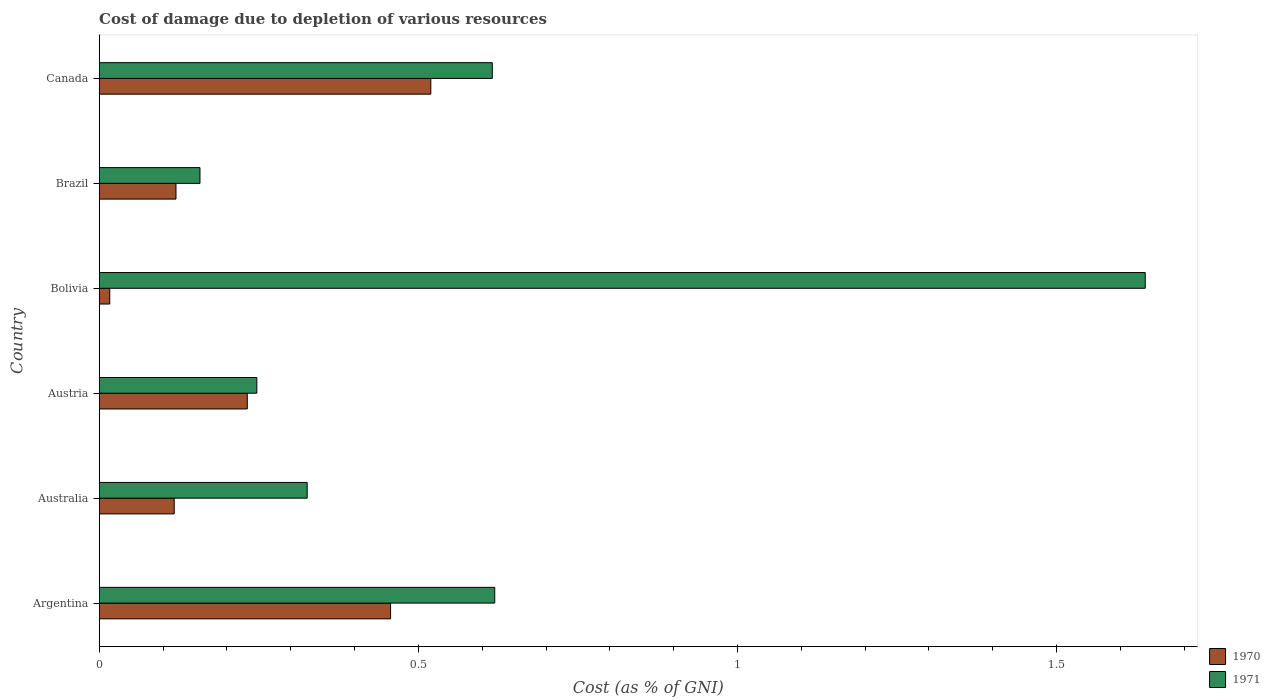How many different coloured bars are there?
Your response must be concise. 2. How many groups of bars are there?
Offer a very short reply. 6. Are the number of bars on each tick of the Y-axis equal?
Offer a terse response. Yes. How many bars are there on the 4th tick from the bottom?
Keep it short and to the point. 2. What is the label of the 6th group of bars from the top?
Offer a terse response. Argentina. In how many cases, is the number of bars for a given country not equal to the number of legend labels?
Offer a very short reply. 0. What is the cost of damage caused due to the depletion of various resources in 1971 in Brazil?
Offer a very short reply. 0.16. Across all countries, what is the maximum cost of damage caused due to the depletion of various resources in 1970?
Provide a short and direct response. 0.52. Across all countries, what is the minimum cost of damage caused due to the depletion of various resources in 1971?
Give a very brief answer. 0.16. In which country was the cost of damage caused due to the depletion of various resources in 1970 maximum?
Offer a very short reply. Canada. What is the total cost of damage caused due to the depletion of various resources in 1970 in the graph?
Keep it short and to the point. 1.46. What is the difference between the cost of damage caused due to the depletion of various resources in 1970 in Australia and that in Brazil?
Make the answer very short. -0. What is the difference between the cost of damage caused due to the depletion of various resources in 1970 in Argentina and the cost of damage caused due to the depletion of various resources in 1971 in Australia?
Your answer should be compact. 0.13. What is the average cost of damage caused due to the depletion of various resources in 1970 per country?
Ensure brevity in your answer.  0.24. What is the difference between the cost of damage caused due to the depletion of various resources in 1970 and cost of damage caused due to the depletion of various resources in 1971 in Australia?
Your response must be concise. -0.21. In how many countries, is the cost of damage caused due to the depletion of various resources in 1970 greater than 0.4 %?
Offer a very short reply. 2. What is the ratio of the cost of damage caused due to the depletion of various resources in 1970 in Australia to that in Bolivia?
Give a very brief answer. 7.12. Is the difference between the cost of damage caused due to the depletion of various resources in 1970 in Australia and Canada greater than the difference between the cost of damage caused due to the depletion of various resources in 1971 in Australia and Canada?
Offer a terse response. No. What is the difference between the highest and the second highest cost of damage caused due to the depletion of various resources in 1971?
Ensure brevity in your answer.  1.02. What is the difference between the highest and the lowest cost of damage caused due to the depletion of various resources in 1971?
Your response must be concise. 1.48. What does the 1st bar from the top in Brazil represents?
Provide a short and direct response. 1971. Are all the bars in the graph horizontal?
Offer a very short reply. Yes. How many countries are there in the graph?
Provide a succinct answer. 6. Are the values on the major ticks of X-axis written in scientific E-notation?
Provide a short and direct response. No. Does the graph contain any zero values?
Your response must be concise. No. Does the graph contain grids?
Offer a terse response. No. Where does the legend appear in the graph?
Keep it short and to the point. Bottom right. How are the legend labels stacked?
Provide a succinct answer. Vertical. What is the title of the graph?
Your answer should be compact. Cost of damage due to depletion of various resources. Does "1966" appear as one of the legend labels in the graph?
Make the answer very short. No. What is the label or title of the X-axis?
Provide a short and direct response. Cost (as % of GNI). What is the label or title of the Y-axis?
Your answer should be compact. Country. What is the Cost (as % of GNI) in 1970 in Argentina?
Your answer should be very brief. 0.46. What is the Cost (as % of GNI) of 1971 in Argentina?
Your answer should be very brief. 0.62. What is the Cost (as % of GNI) of 1970 in Australia?
Offer a terse response. 0.12. What is the Cost (as % of GNI) of 1971 in Australia?
Ensure brevity in your answer.  0.33. What is the Cost (as % of GNI) in 1970 in Austria?
Provide a succinct answer. 0.23. What is the Cost (as % of GNI) in 1971 in Austria?
Make the answer very short. 0.25. What is the Cost (as % of GNI) of 1970 in Bolivia?
Ensure brevity in your answer.  0.02. What is the Cost (as % of GNI) in 1971 in Bolivia?
Ensure brevity in your answer.  1.64. What is the Cost (as % of GNI) of 1970 in Brazil?
Offer a very short reply. 0.12. What is the Cost (as % of GNI) in 1971 in Brazil?
Ensure brevity in your answer.  0.16. What is the Cost (as % of GNI) of 1970 in Canada?
Offer a terse response. 0.52. What is the Cost (as % of GNI) in 1971 in Canada?
Your response must be concise. 0.62. Across all countries, what is the maximum Cost (as % of GNI) in 1970?
Provide a succinct answer. 0.52. Across all countries, what is the maximum Cost (as % of GNI) in 1971?
Offer a very short reply. 1.64. Across all countries, what is the minimum Cost (as % of GNI) of 1970?
Make the answer very short. 0.02. Across all countries, what is the minimum Cost (as % of GNI) in 1971?
Your answer should be very brief. 0.16. What is the total Cost (as % of GNI) in 1970 in the graph?
Your response must be concise. 1.46. What is the total Cost (as % of GNI) of 1971 in the graph?
Ensure brevity in your answer.  3.6. What is the difference between the Cost (as % of GNI) of 1970 in Argentina and that in Australia?
Ensure brevity in your answer.  0.34. What is the difference between the Cost (as % of GNI) of 1971 in Argentina and that in Australia?
Offer a very short reply. 0.29. What is the difference between the Cost (as % of GNI) of 1970 in Argentina and that in Austria?
Ensure brevity in your answer.  0.22. What is the difference between the Cost (as % of GNI) in 1971 in Argentina and that in Austria?
Give a very brief answer. 0.37. What is the difference between the Cost (as % of GNI) of 1970 in Argentina and that in Bolivia?
Your response must be concise. 0.44. What is the difference between the Cost (as % of GNI) in 1971 in Argentina and that in Bolivia?
Provide a short and direct response. -1.02. What is the difference between the Cost (as % of GNI) in 1970 in Argentina and that in Brazil?
Your answer should be compact. 0.34. What is the difference between the Cost (as % of GNI) of 1971 in Argentina and that in Brazil?
Your answer should be very brief. 0.46. What is the difference between the Cost (as % of GNI) of 1970 in Argentina and that in Canada?
Keep it short and to the point. -0.06. What is the difference between the Cost (as % of GNI) of 1971 in Argentina and that in Canada?
Give a very brief answer. 0. What is the difference between the Cost (as % of GNI) of 1970 in Australia and that in Austria?
Provide a succinct answer. -0.11. What is the difference between the Cost (as % of GNI) in 1971 in Australia and that in Austria?
Keep it short and to the point. 0.08. What is the difference between the Cost (as % of GNI) in 1970 in Australia and that in Bolivia?
Your answer should be very brief. 0.1. What is the difference between the Cost (as % of GNI) of 1971 in Australia and that in Bolivia?
Keep it short and to the point. -1.31. What is the difference between the Cost (as % of GNI) of 1970 in Australia and that in Brazil?
Offer a terse response. -0. What is the difference between the Cost (as % of GNI) of 1971 in Australia and that in Brazil?
Keep it short and to the point. 0.17. What is the difference between the Cost (as % of GNI) of 1970 in Australia and that in Canada?
Make the answer very short. -0.4. What is the difference between the Cost (as % of GNI) in 1971 in Australia and that in Canada?
Ensure brevity in your answer.  -0.29. What is the difference between the Cost (as % of GNI) of 1970 in Austria and that in Bolivia?
Make the answer very short. 0.22. What is the difference between the Cost (as % of GNI) of 1971 in Austria and that in Bolivia?
Ensure brevity in your answer.  -1.39. What is the difference between the Cost (as % of GNI) of 1970 in Austria and that in Brazil?
Your answer should be very brief. 0.11. What is the difference between the Cost (as % of GNI) in 1971 in Austria and that in Brazil?
Offer a terse response. 0.09. What is the difference between the Cost (as % of GNI) of 1970 in Austria and that in Canada?
Offer a terse response. -0.29. What is the difference between the Cost (as % of GNI) in 1971 in Austria and that in Canada?
Offer a terse response. -0.37. What is the difference between the Cost (as % of GNI) in 1970 in Bolivia and that in Brazil?
Offer a terse response. -0.1. What is the difference between the Cost (as % of GNI) of 1971 in Bolivia and that in Brazil?
Make the answer very short. 1.48. What is the difference between the Cost (as % of GNI) of 1970 in Bolivia and that in Canada?
Provide a short and direct response. -0.5. What is the difference between the Cost (as % of GNI) of 1970 in Brazil and that in Canada?
Your answer should be very brief. -0.4. What is the difference between the Cost (as % of GNI) in 1971 in Brazil and that in Canada?
Your answer should be compact. -0.46. What is the difference between the Cost (as % of GNI) of 1970 in Argentina and the Cost (as % of GNI) of 1971 in Australia?
Keep it short and to the point. 0.13. What is the difference between the Cost (as % of GNI) of 1970 in Argentina and the Cost (as % of GNI) of 1971 in Austria?
Offer a terse response. 0.21. What is the difference between the Cost (as % of GNI) of 1970 in Argentina and the Cost (as % of GNI) of 1971 in Bolivia?
Give a very brief answer. -1.18. What is the difference between the Cost (as % of GNI) in 1970 in Argentina and the Cost (as % of GNI) in 1971 in Brazil?
Offer a very short reply. 0.3. What is the difference between the Cost (as % of GNI) of 1970 in Argentina and the Cost (as % of GNI) of 1971 in Canada?
Offer a very short reply. -0.16. What is the difference between the Cost (as % of GNI) of 1970 in Australia and the Cost (as % of GNI) of 1971 in Austria?
Provide a succinct answer. -0.13. What is the difference between the Cost (as % of GNI) of 1970 in Australia and the Cost (as % of GNI) of 1971 in Bolivia?
Offer a terse response. -1.52. What is the difference between the Cost (as % of GNI) in 1970 in Australia and the Cost (as % of GNI) in 1971 in Brazil?
Keep it short and to the point. -0.04. What is the difference between the Cost (as % of GNI) of 1970 in Australia and the Cost (as % of GNI) of 1971 in Canada?
Make the answer very short. -0.5. What is the difference between the Cost (as % of GNI) of 1970 in Austria and the Cost (as % of GNI) of 1971 in Bolivia?
Ensure brevity in your answer.  -1.41. What is the difference between the Cost (as % of GNI) of 1970 in Austria and the Cost (as % of GNI) of 1971 in Brazil?
Make the answer very short. 0.07. What is the difference between the Cost (as % of GNI) of 1970 in Austria and the Cost (as % of GNI) of 1971 in Canada?
Your response must be concise. -0.38. What is the difference between the Cost (as % of GNI) of 1970 in Bolivia and the Cost (as % of GNI) of 1971 in Brazil?
Your response must be concise. -0.14. What is the difference between the Cost (as % of GNI) in 1970 in Bolivia and the Cost (as % of GNI) in 1971 in Canada?
Offer a very short reply. -0.6. What is the difference between the Cost (as % of GNI) of 1970 in Brazil and the Cost (as % of GNI) of 1971 in Canada?
Offer a very short reply. -0.5. What is the average Cost (as % of GNI) in 1970 per country?
Offer a very short reply. 0.24. What is the average Cost (as % of GNI) in 1971 per country?
Keep it short and to the point. 0.6. What is the difference between the Cost (as % of GNI) in 1970 and Cost (as % of GNI) in 1971 in Argentina?
Provide a short and direct response. -0.16. What is the difference between the Cost (as % of GNI) of 1970 and Cost (as % of GNI) of 1971 in Australia?
Offer a terse response. -0.21. What is the difference between the Cost (as % of GNI) of 1970 and Cost (as % of GNI) of 1971 in Austria?
Your response must be concise. -0.01. What is the difference between the Cost (as % of GNI) in 1970 and Cost (as % of GNI) in 1971 in Bolivia?
Your answer should be compact. -1.62. What is the difference between the Cost (as % of GNI) of 1970 and Cost (as % of GNI) of 1971 in Brazil?
Ensure brevity in your answer.  -0.04. What is the difference between the Cost (as % of GNI) of 1970 and Cost (as % of GNI) of 1971 in Canada?
Offer a very short reply. -0.1. What is the ratio of the Cost (as % of GNI) in 1970 in Argentina to that in Australia?
Ensure brevity in your answer.  3.89. What is the ratio of the Cost (as % of GNI) in 1971 in Argentina to that in Australia?
Your answer should be very brief. 1.9. What is the ratio of the Cost (as % of GNI) of 1970 in Argentina to that in Austria?
Your response must be concise. 1.97. What is the ratio of the Cost (as % of GNI) in 1971 in Argentina to that in Austria?
Your answer should be compact. 2.51. What is the ratio of the Cost (as % of GNI) in 1970 in Argentina to that in Bolivia?
Ensure brevity in your answer.  27.67. What is the ratio of the Cost (as % of GNI) in 1971 in Argentina to that in Bolivia?
Provide a succinct answer. 0.38. What is the ratio of the Cost (as % of GNI) in 1970 in Argentina to that in Brazil?
Provide a short and direct response. 3.8. What is the ratio of the Cost (as % of GNI) in 1971 in Argentina to that in Brazil?
Provide a short and direct response. 3.92. What is the ratio of the Cost (as % of GNI) of 1970 in Argentina to that in Canada?
Your response must be concise. 0.88. What is the ratio of the Cost (as % of GNI) of 1970 in Australia to that in Austria?
Give a very brief answer. 0.51. What is the ratio of the Cost (as % of GNI) of 1971 in Australia to that in Austria?
Offer a terse response. 1.32. What is the ratio of the Cost (as % of GNI) in 1970 in Australia to that in Bolivia?
Your answer should be very brief. 7.12. What is the ratio of the Cost (as % of GNI) of 1971 in Australia to that in Bolivia?
Offer a very short reply. 0.2. What is the ratio of the Cost (as % of GNI) of 1970 in Australia to that in Brazil?
Offer a terse response. 0.98. What is the ratio of the Cost (as % of GNI) of 1971 in Australia to that in Brazil?
Your response must be concise. 2.06. What is the ratio of the Cost (as % of GNI) in 1970 in Australia to that in Canada?
Offer a very short reply. 0.23. What is the ratio of the Cost (as % of GNI) in 1971 in Australia to that in Canada?
Your response must be concise. 0.53. What is the ratio of the Cost (as % of GNI) in 1970 in Austria to that in Bolivia?
Offer a very short reply. 14.06. What is the ratio of the Cost (as % of GNI) in 1971 in Austria to that in Bolivia?
Provide a succinct answer. 0.15. What is the ratio of the Cost (as % of GNI) in 1970 in Austria to that in Brazil?
Provide a succinct answer. 1.93. What is the ratio of the Cost (as % of GNI) of 1971 in Austria to that in Brazil?
Make the answer very short. 1.56. What is the ratio of the Cost (as % of GNI) of 1970 in Austria to that in Canada?
Make the answer very short. 0.45. What is the ratio of the Cost (as % of GNI) of 1971 in Austria to that in Canada?
Provide a short and direct response. 0.4. What is the ratio of the Cost (as % of GNI) of 1970 in Bolivia to that in Brazil?
Make the answer very short. 0.14. What is the ratio of the Cost (as % of GNI) of 1971 in Bolivia to that in Brazil?
Your response must be concise. 10.38. What is the ratio of the Cost (as % of GNI) of 1970 in Bolivia to that in Canada?
Ensure brevity in your answer.  0.03. What is the ratio of the Cost (as % of GNI) of 1971 in Bolivia to that in Canada?
Provide a short and direct response. 2.66. What is the ratio of the Cost (as % of GNI) in 1970 in Brazil to that in Canada?
Keep it short and to the point. 0.23. What is the ratio of the Cost (as % of GNI) in 1971 in Brazil to that in Canada?
Offer a very short reply. 0.26. What is the difference between the highest and the second highest Cost (as % of GNI) in 1970?
Offer a terse response. 0.06. What is the difference between the highest and the second highest Cost (as % of GNI) of 1971?
Your response must be concise. 1.02. What is the difference between the highest and the lowest Cost (as % of GNI) in 1970?
Your response must be concise. 0.5. What is the difference between the highest and the lowest Cost (as % of GNI) of 1971?
Offer a very short reply. 1.48. 